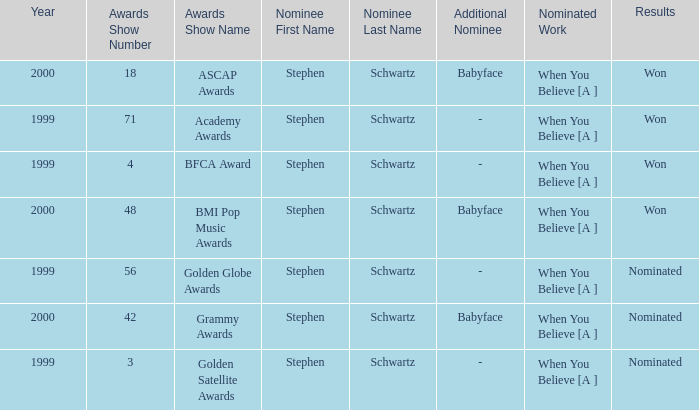What was the winning work nominated in 2000? When You Believe [A ], When You Believe [A ]. Can you parse all the data within this table? {'header': ['Year', 'Awards Show Number', 'Awards Show Name', 'Nominee First Name', 'Nominee Last Name', 'Additional Nominee', 'Nominated Work', 'Results'], 'rows': [['2000', '18', 'ASCAP Awards', 'Stephen', 'Schwartz', 'Babyface', 'When You Believe [A ]', 'Won'], ['1999', '71', 'Academy Awards', 'Stephen', 'Schwartz', '-', 'When You Believe [A ]', 'Won'], ['1999', '4', 'BFCA Award', 'Stephen', 'Schwartz', '-', 'When You Believe [A ]', 'Won'], ['2000', '48', 'BMI Pop Music Awards', 'Stephen', 'Schwartz', 'Babyface', 'When You Believe [A ]', 'Won'], ['1999', '56', 'Golden Globe Awards', 'Stephen', 'Schwartz', '-', 'When You Believe [A ]', 'Nominated'], ['2000', '42', 'Grammy Awards', 'Stephen', 'Schwartz', 'Babyface', 'When You Believe [A ]', 'Nominated'], ['1999', '3', 'Golden Satellite Awards', 'Stephen', 'Schwartz', '-', 'When You Believe [A ]', 'Nominated']]} 